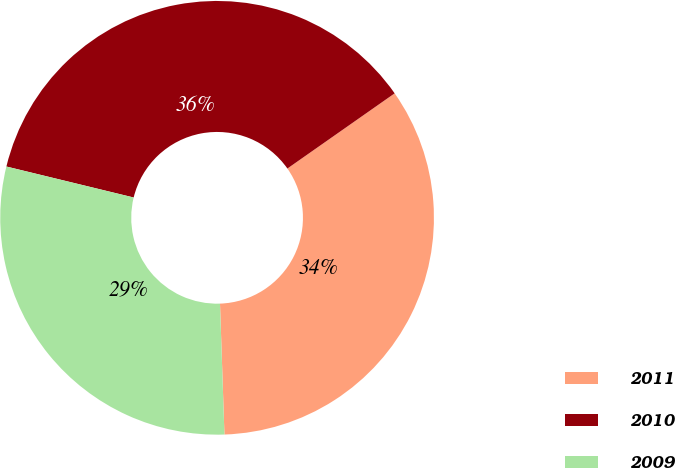<chart> <loc_0><loc_0><loc_500><loc_500><pie_chart><fcel>2011<fcel>2010<fcel>2009<nl><fcel>34.19%<fcel>36.47%<fcel>29.34%<nl></chart> 